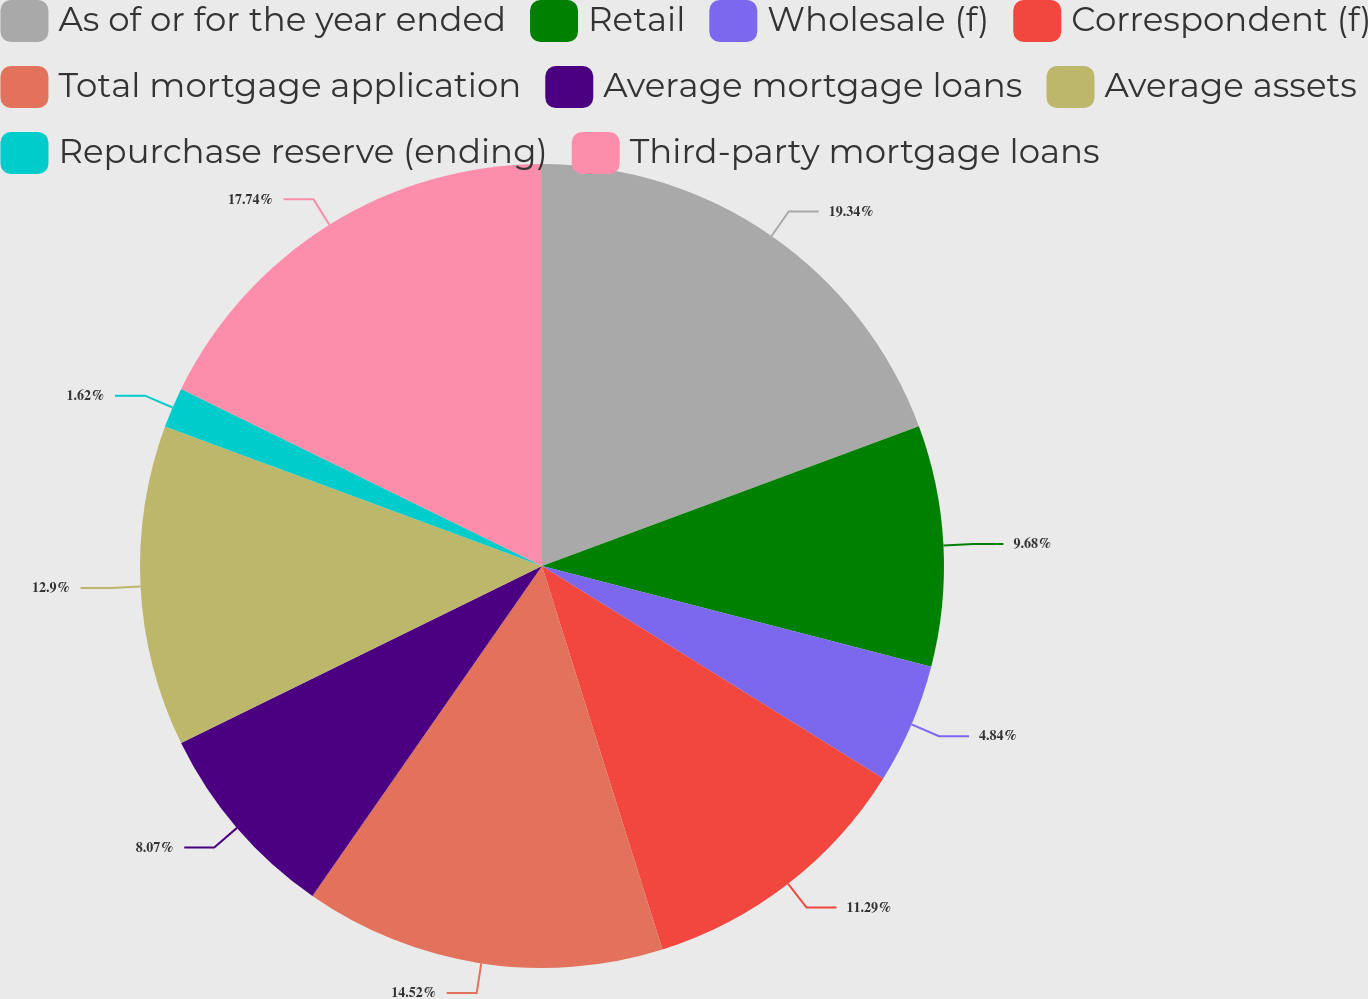Convert chart. <chart><loc_0><loc_0><loc_500><loc_500><pie_chart><fcel>As of or for the year ended<fcel>Retail<fcel>Wholesale (f)<fcel>Correspondent (f)<fcel>Total mortgage application<fcel>Average mortgage loans<fcel>Average assets<fcel>Repurchase reserve (ending)<fcel>Third-party mortgage loans<nl><fcel>19.35%<fcel>9.68%<fcel>4.84%<fcel>11.29%<fcel>14.52%<fcel>8.07%<fcel>12.9%<fcel>1.62%<fcel>17.74%<nl></chart> 